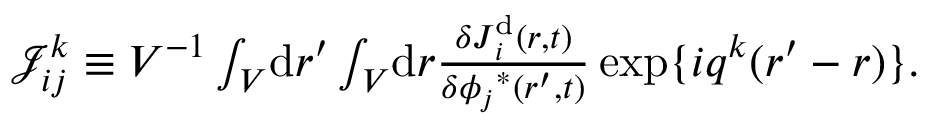<formula> <loc_0><loc_0><loc_500><loc_500>\begin{array} { r } { \mathcal { J } _ { i j } ^ { k } \equiv V ^ { - 1 } \int _ { V } \, d r ^ { \prime } \int _ { V } \, d r \frac { \delta J _ { i } ^ { d } ( r , t ) } { \delta { \phi _ { j } } ^ { * } ( r ^ { \prime } , t ) } \, e x p \{ i q ^ { k } ( r ^ { \prime } - r ) \} . } \end{array}</formula> 